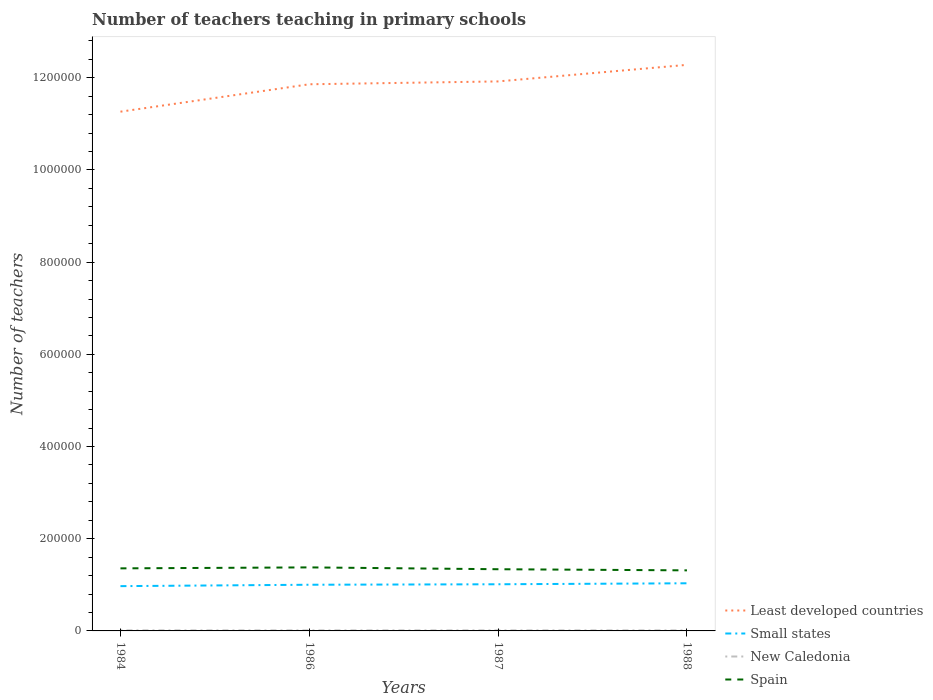Is the number of lines equal to the number of legend labels?
Offer a terse response. Yes. Across all years, what is the maximum number of teachers teaching in primary schools in New Caledonia?
Your response must be concise. 1128. What is the total number of teachers teaching in primary schools in Spain in the graph?
Provide a short and direct response. -2092. What is the difference between the highest and the second highest number of teachers teaching in primary schools in Least developed countries?
Offer a terse response. 1.02e+05. How many lines are there?
Your response must be concise. 4. How many years are there in the graph?
Keep it short and to the point. 4. What is the difference between two consecutive major ticks on the Y-axis?
Your answer should be very brief. 2.00e+05. Does the graph contain any zero values?
Ensure brevity in your answer.  No. Does the graph contain grids?
Offer a very short reply. No. How many legend labels are there?
Keep it short and to the point. 4. How are the legend labels stacked?
Offer a very short reply. Vertical. What is the title of the graph?
Provide a short and direct response. Number of teachers teaching in primary schools. What is the label or title of the Y-axis?
Your answer should be compact. Number of teachers. What is the Number of teachers of Least developed countries in 1984?
Give a very brief answer. 1.13e+06. What is the Number of teachers of Small states in 1984?
Provide a short and direct response. 9.72e+04. What is the Number of teachers of New Caledonia in 1984?
Offer a very short reply. 1175. What is the Number of teachers of Spain in 1984?
Make the answer very short. 1.36e+05. What is the Number of teachers of Least developed countries in 1986?
Your answer should be very brief. 1.19e+06. What is the Number of teachers in Small states in 1986?
Make the answer very short. 1.00e+05. What is the Number of teachers in New Caledonia in 1986?
Provide a short and direct response. 1153. What is the Number of teachers of Spain in 1986?
Give a very brief answer. 1.38e+05. What is the Number of teachers of Least developed countries in 1987?
Make the answer very short. 1.19e+06. What is the Number of teachers of Small states in 1987?
Offer a very short reply. 1.01e+05. What is the Number of teachers of New Caledonia in 1987?
Ensure brevity in your answer.  1143. What is the Number of teachers in Spain in 1987?
Your answer should be compact. 1.34e+05. What is the Number of teachers in Least developed countries in 1988?
Your response must be concise. 1.23e+06. What is the Number of teachers in Small states in 1988?
Your answer should be very brief. 1.03e+05. What is the Number of teachers of New Caledonia in 1988?
Keep it short and to the point. 1128. What is the Number of teachers in Spain in 1988?
Your response must be concise. 1.31e+05. Across all years, what is the maximum Number of teachers of Least developed countries?
Your answer should be very brief. 1.23e+06. Across all years, what is the maximum Number of teachers in Small states?
Provide a short and direct response. 1.03e+05. Across all years, what is the maximum Number of teachers of New Caledonia?
Offer a terse response. 1175. Across all years, what is the maximum Number of teachers in Spain?
Keep it short and to the point. 1.38e+05. Across all years, what is the minimum Number of teachers of Least developed countries?
Keep it short and to the point. 1.13e+06. Across all years, what is the minimum Number of teachers of Small states?
Provide a succinct answer. 9.72e+04. Across all years, what is the minimum Number of teachers in New Caledonia?
Make the answer very short. 1128. Across all years, what is the minimum Number of teachers of Spain?
Make the answer very short. 1.31e+05. What is the total Number of teachers of Least developed countries in the graph?
Provide a succinct answer. 4.73e+06. What is the total Number of teachers in Small states in the graph?
Offer a terse response. 4.02e+05. What is the total Number of teachers in New Caledonia in the graph?
Keep it short and to the point. 4599. What is the total Number of teachers in Spain in the graph?
Provide a succinct answer. 5.39e+05. What is the difference between the Number of teachers of Least developed countries in 1984 and that in 1986?
Give a very brief answer. -5.94e+04. What is the difference between the Number of teachers of Small states in 1984 and that in 1986?
Provide a short and direct response. -3015.23. What is the difference between the Number of teachers of Spain in 1984 and that in 1986?
Offer a terse response. -2092. What is the difference between the Number of teachers of Least developed countries in 1984 and that in 1987?
Your response must be concise. -6.56e+04. What is the difference between the Number of teachers of Small states in 1984 and that in 1987?
Give a very brief answer. -4055.76. What is the difference between the Number of teachers of Spain in 1984 and that in 1987?
Your response must be concise. 1885. What is the difference between the Number of teachers in Least developed countries in 1984 and that in 1988?
Your answer should be very brief. -1.02e+05. What is the difference between the Number of teachers in Small states in 1984 and that in 1988?
Keep it short and to the point. -6192.02. What is the difference between the Number of teachers in New Caledonia in 1984 and that in 1988?
Offer a very short reply. 47. What is the difference between the Number of teachers in Spain in 1984 and that in 1988?
Provide a succinct answer. 4326. What is the difference between the Number of teachers in Least developed countries in 1986 and that in 1987?
Your answer should be very brief. -6182.38. What is the difference between the Number of teachers of Small states in 1986 and that in 1987?
Your answer should be compact. -1040.53. What is the difference between the Number of teachers of New Caledonia in 1986 and that in 1987?
Your answer should be compact. 10. What is the difference between the Number of teachers in Spain in 1986 and that in 1987?
Ensure brevity in your answer.  3977. What is the difference between the Number of teachers of Least developed countries in 1986 and that in 1988?
Ensure brevity in your answer.  -4.21e+04. What is the difference between the Number of teachers in Small states in 1986 and that in 1988?
Give a very brief answer. -3176.79. What is the difference between the Number of teachers in Spain in 1986 and that in 1988?
Keep it short and to the point. 6418. What is the difference between the Number of teachers of Least developed countries in 1987 and that in 1988?
Make the answer very short. -3.59e+04. What is the difference between the Number of teachers of Small states in 1987 and that in 1988?
Provide a short and direct response. -2136.26. What is the difference between the Number of teachers in New Caledonia in 1987 and that in 1988?
Make the answer very short. 15. What is the difference between the Number of teachers of Spain in 1987 and that in 1988?
Give a very brief answer. 2441. What is the difference between the Number of teachers in Least developed countries in 1984 and the Number of teachers in Small states in 1986?
Provide a succinct answer. 1.03e+06. What is the difference between the Number of teachers of Least developed countries in 1984 and the Number of teachers of New Caledonia in 1986?
Ensure brevity in your answer.  1.13e+06. What is the difference between the Number of teachers in Least developed countries in 1984 and the Number of teachers in Spain in 1986?
Your answer should be very brief. 9.89e+05. What is the difference between the Number of teachers in Small states in 1984 and the Number of teachers in New Caledonia in 1986?
Provide a short and direct response. 9.60e+04. What is the difference between the Number of teachers in Small states in 1984 and the Number of teachers in Spain in 1986?
Your answer should be very brief. -4.07e+04. What is the difference between the Number of teachers of New Caledonia in 1984 and the Number of teachers of Spain in 1986?
Make the answer very short. -1.37e+05. What is the difference between the Number of teachers in Least developed countries in 1984 and the Number of teachers in Small states in 1987?
Your response must be concise. 1.03e+06. What is the difference between the Number of teachers of Least developed countries in 1984 and the Number of teachers of New Caledonia in 1987?
Your answer should be very brief. 1.13e+06. What is the difference between the Number of teachers of Least developed countries in 1984 and the Number of teachers of Spain in 1987?
Give a very brief answer. 9.93e+05. What is the difference between the Number of teachers in Small states in 1984 and the Number of teachers in New Caledonia in 1987?
Keep it short and to the point. 9.60e+04. What is the difference between the Number of teachers in Small states in 1984 and the Number of teachers in Spain in 1987?
Provide a short and direct response. -3.67e+04. What is the difference between the Number of teachers of New Caledonia in 1984 and the Number of teachers of Spain in 1987?
Offer a very short reply. -1.33e+05. What is the difference between the Number of teachers of Least developed countries in 1984 and the Number of teachers of Small states in 1988?
Your answer should be compact. 1.02e+06. What is the difference between the Number of teachers of Least developed countries in 1984 and the Number of teachers of New Caledonia in 1988?
Your answer should be very brief. 1.13e+06. What is the difference between the Number of teachers in Least developed countries in 1984 and the Number of teachers in Spain in 1988?
Keep it short and to the point. 9.95e+05. What is the difference between the Number of teachers in Small states in 1984 and the Number of teachers in New Caledonia in 1988?
Make the answer very short. 9.60e+04. What is the difference between the Number of teachers in Small states in 1984 and the Number of teachers in Spain in 1988?
Provide a short and direct response. -3.42e+04. What is the difference between the Number of teachers in New Caledonia in 1984 and the Number of teachers in Spain in 1988?
Your answer should be compact. -1.30e+05. What is the difference between the Number of teachers in Least developed countries in 1986 and the Number of teachers in Small states in 1987?
Give a very brief answer. 1.08e+06. What is the difference between the Number of teachers in Least developed countries in 1986 and the Number of teachers in New Caledonia in 1987?
Make the answer very short. 1.18e+06. What is the difference between the Number of teachers in Least developed countries in 1986 and the Number of teachers in Spain in 1987?
Keep it short and to the point. 1.05e+06. What is the difference between the Number of teachers in Small states in 1986 and the Number of teachers in New Caledonia in 1987?
Your response must be concise. 9.90e+04. What is the difference between the Number of teachers in Small states in 1986 and the Number of teachers in Spain in 1987?
Your response must be concise. -3.37e+04. What is the difference between the Number of teachers of New Caledonia in 1986 and the Number of teachers of Spain in 1987?
Your answer should be very brief. -1.33e+05. What is the difference between the Number of teachers of Least developed countries in 1986 and the Number of teachers of Small states in 1988?
Your answer should be very brief. 1.08e+06. What is the difference between the Number of teachers in Least developed countries in 1986 and the Number of teachers in New Caledonia in 1988?
Provide a succinct answer. 1.18e+06. What is the difference between the Number of teachers in Least developed countries in 1986 and the Number of teachers in Spain in 1988?
Keep it short and to the point. 1.05e+06. What is the difference between the Number of teachers in Small states in 1986 and the Number of teachers in New Caledonia in 1988?
Provide a succinct answer. 9.90e+04. What is the difference between the Number of teachers in Small states in 1986 and the Number of teachers in Spain in 1988?
Your answer should be very brief. -3.12e+04. What is the difference between the Number of teachers in New Caledonia in 1986 and the Number of teachers in Spain in 1988?
Provide a short and direct response. -1.30e+05. What is the difference between the Number of teachers in Least developed countries in 1987 and the Number of teachers in Small states in 1988?
Keep it short and to the point. 1.09e+06. What is the difference between the Number of teachers of Least developed countries in 1987 and the Number of teachers of New Caledonia in 1988?
Offer a terse response. 1.19e+06. What is the difference between the Number of teachers in Least developed countries in 1987 and the Number of teachers in Spain in 1988?
Ensure brevity in your answer.  1.06e+06. What is the difference between the Number of teachers in Small states in 1987 and the Number of teachers in New Caledonia in 1988?
Keep it short and to the point. 1.00e+05. What is the difference between the Number of teachers of Small states in 1987 and the Number of teachers of Spain in 1988?
Your answer should be compact. -3.02e+04. What is the difference between the Number of teachers in New Caledonia in 1987 and the Number of teachers in Spain in 1988?
Your response must be concise. -1.30e+05. What is the average Number of teachers in Least developed countries per year?
Keep it short and to the point. 1.18e+06. What is the average Number of teachers in Small states per year?
Ensure brevity in your answer.  1.00e+05. What is the average Number of teachers of New Caledonia per year?
Provide a succinct answer. 1149.75. What is the average Number of teachers in Spain per year?
Give a very brief answer. 1.35e+05. In the year 1984, what is the difference between the Number of teachers in Least developed countries and Number of teachers in Small states?
Your answer should be compact. 1.03e+06. In the year 1984, what is the difference between the Number of teachers of Least developed countries and Number of teachers of New Caledonia?
Offer a terse response. 1.13e+06. In the year 1984, what is the difference between the Number of teachers of Least developed countries and Number of teachers of Spain?
Your answer should be very brief. 9.91e+05. In the year 1984, what is the difference between the Number of teachers of Small states and Number of teachers of New Caledonia?
Your answer should be very brief. 9.60e+04. In the year 1984, what is the difference between the Number of teachers of Small states and Number of teachers of Spain?
Keep it short and to the point. -3.86e+04. In the year 1984, what is the difference between the Number of teachers in New Caledonia and Number of teachers in Spain?
Provide a succinct answer. -1.35e+05. In the year 1986, what is the difference between the Number of teachers of Least developed countries and Number of teachers of Small states?
Keep it short and to the point. 1.09e+06. In the year 1986, what is the difference between the Number of teachers of Least developed countries and Number of teachers of New Caledonia?
Ensure brevity in your answer.  1.18e+06. In the year 1986, what is the difference between the Number of teachers in Least developed countries and Number of teachers in Spain?
Give a very brief answer. 1.05e+06. In the year 1986, what is the difference between the Number of teachers in Small states and Number of teachers in New Caledonia?
Your answer should be compact. 9.90e+04. In the year 1986, what is the difference between the Number of teachers of Small states and Number of teachers of Spain?
Offer a terse response. -3.76e+04. In the year 1986, what is the difference between the Number of teachers of New Caledonia and Number of teachers of Spain?
Provide a short and direct response. -1.37e+05. In the year 1987, what is the difference between the Number of teachers in Least developed countries and Number of teachers in Small states?
Your answer should be compact. 1.09e+06. In the year 1987, what is the difference between the Number of teachers of Least developed countries and Number of teachers of New Caledonia?
Keep it short and to the point. 1.19e+06. In the year 1987, what is the difference between the Number of teachers of Least developed countries and Number of teachers of Spain?
Offer a very short reply. 1.06e+06. In the year 1987, what is the difference between the Number of teachers of Small states and Number of teachers of New Caledonia?
Ensure brevity in your answer.  1.00e+05. In the year 1987, what is the difference between the Number of teachers in Small states and Number of teachers in Spain?
Make the answer very short. -3.26e+04. In the year 1987, what is the difference between the Number of teachers in New Caledonia and Number of teachers in Spain?
Make the answer very short. -1.33e+05. In the year 1988, what is the difference between the Number of teachers of Least developed countries and Number of teachers of Small states?
Your answer should be compact. 1.12e+06. In the year 1988, what is the difference between the Number of teachers of Least developed countries and Number of teachers of New Caledonia?
Your response must be concise. 1.23e+06. In the year 1988, what is the difference between the Number of teachers of Least developed countries and Number of teachers of Spain?
Your answer should be very brief. 1.10e+06. In the year 1988, what is the difference between the Number of teachers in Small states and Number of teachers in New Caledonia?
Your response must be concise. 1.02e+05. In the year 1988, what is the difference between the Number of teachers of Small states and Number of teachers of Spain?
Make the answer very short. -2.80e+04. In the year 1988, what is the difference between the Number of teachers in New Caledonia and Number of teachers in Spain?
Make the answer very short. -1.30e+05. What is the ratio of the Number of teachers of Least developed countries in 1984 to that in 1986?
Your response must be concise. 0.95. What is the ratio of the Number of teachers in Small states in 1984 to that in 1986?
Offer a very short reply. 0.97. What is the ratio of the Number of teachers of New Caledonia in 1984 to that in 1986?
Give a very brief answer. 1.02. What is the ratio of the Number of teachers of Spain in 1984 to that in 1986?
Ensure brevity in your answer.  0.98. What is the ratio of the Number of teachers in Least developed countries in 1984 to that in 1987?
Offer a terse response. 0.94. What is the ratio of the Number of teachers of Small states in 1984 to that in 1987?
Provide a succinct answer. 0.96. What is the ratio of the Number of teachers of New Caledonia in 1984 to that in 1987?
Keep it short and to the point. 1.03. What is the ratio of the Number of teachers of Spain in 1984 to that in 1987?
Provide a succinct answer. 1.01. What is the ratio of the Number of teachers in Least developed countries in 1984 to that in 1988?
Offer a terse response. 0.92. What is the ratio of the Number of teachers in Small states in 1984 to that in 1988?
Give a very brief answer. 0.94. What is the ratio of the Number of teachers in New Caledonia in 1984 to that in 1988?
Keep it short and to the point. 1.04. What is the ratio of the Number of teachers of Spain in 1984 to that in 1988?
Your response must be concise. 1.03. What is the ratio of the Number of teachers in Least developed countries in 1986 to that in 1987?
Offer a very short reply. 0.99. What is the ratio of the Number of teachers of New Caledonia in 1986 to that in 1987?
Offer a very short reply. 1.01. What is the ratio of the Number of teachers in Spain in 1986 to that in 1987?
Provide a short and direct response. 1.03. What is the ratio of the Number of teachers of Least developed countries in 1986 to that in 1988?
Your answer should be very brief. 0.97. What is the ratio of the Number of teachers in Small states in 1986 to that in 1988?
Provide a short and direct response. 0.97. What is the ratio of the Number of teachers in New Caledonia in 1986 to that in 1988?
Keep it short and to the point. 1.02. What is the ratio of the Number of teachers of Spain in 1986 to that in 1988?
Provide a short and direct response. 1.05. What is the ratio of the Number of teachers of Least developed countries in 1987 to that in 1988?
Give a very brief answer. 0.97. What is the ratio of the Number of teachers of Small states in 1987 to that in 1988?
Give a very brief answer. 0.98. What is the ratio of the Number of teachers of New Caledonia in 1987 to that in 1988?
Provide a succinct answer. 1.01. What is the ratio of the Number of teachers in Spain in 1987 to that in 1988?
Provide a succinct answer. 1.02. What is the difference between the highest and the second highest Number of teachers of Least developed countries?
Your answer should be compact. 3.59e+04. What is the difference between the highest and the second highest Number of teachers in Small states?
Provide a succinct answer. 2136.26. What is the difference between the highest and the second highest Number of teachers of New Caledonia?
Provide a short and direct response. 22. What is the difference between the highest and the second highest Number of teachers in Spain?
Your response must be concise. 2092. What is the difference between the highest and the lowest Number of teachers of Least developed countries?
Provide a succinct answer. 1.02e+05. What is the difference between the highest and the lowest Number of teachers in Small states?
Give a very brief answer. 6192.02. What is the difference between the highest and the lowest Number of teachers in Spain?
Your answer should be compact. 6418. 